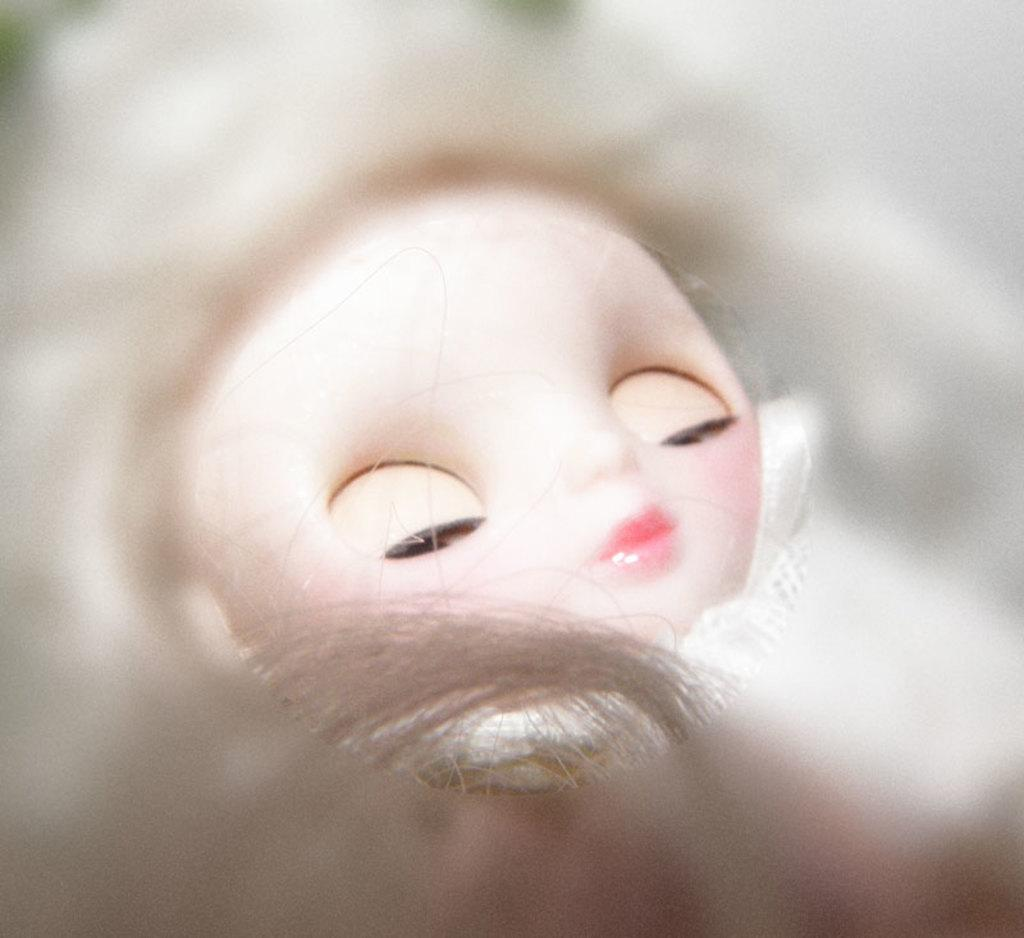What is the main subject of the image? There is a doll in the image. What feature of the doll can be seen in the image? Hair is visible in the image. Can you describe the background of the image? The background of the image is blurry. What type of laborer can be seen working in the background of the image? There is no laborer present in the image; it only features a doll and its hair. How many family members are visible in the image? There are no family members present in the image, only a doll. 